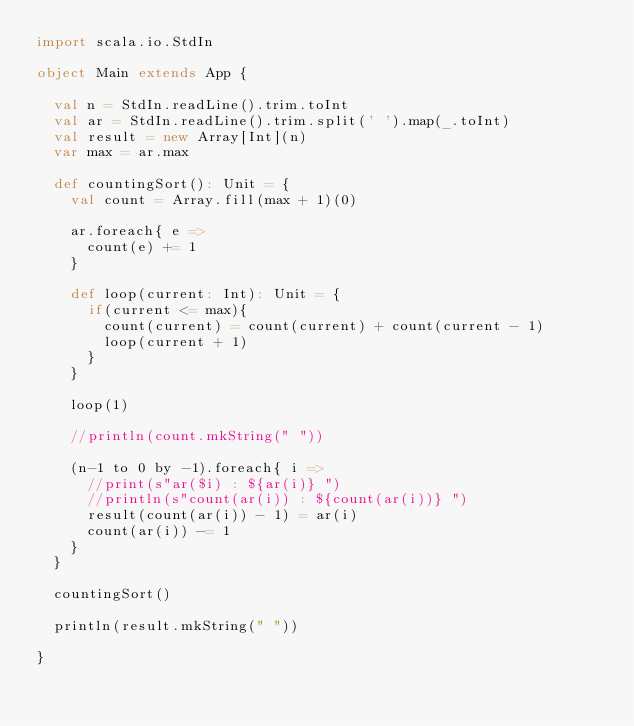<code> <loc_0><loc_0><loc_500><loc_500><_Scala_>import scala.io.StdIn

object Main extends App {
  
  val n = StdIn.readLine().trim.toInt
  val ar = StdIn.readLine().trim.split(' ').map(_.toInt)
  val result = new Array[Int](n)
  var max = ar.max
  
  def countingSort(): Unit = {
    val count = Array.fill(max + 1)(0)

    ar.foreach{ e =>
      count(e) += 1
    }

    def loop(current: Int): Unit = {
      if(current <= max){
        count(current) = count(current) + count(current - 1)
        loop(current + 1)
      } 
    }

    loop(1)

    //println(count.mkString(" "))
    
    (n-1 to 0 by -1).foreach{ i =>
      //print(s"ar($i) : ${ar(i)} ")
      //println(s"count(ar(i)) : ${count(ar(i))} ")
      result(count(ar(i)) - 1) = ar(i)
      count(ar(i)) -= 1
    }
  }
  
  countingSort()
  
  println(result.mkString(" "))

}
</code> 